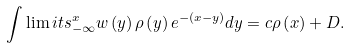<formula> <loc_0><loc_0><loc_500><loc_500>\int \lim i t s _ { - \infty } ^ { x } w \left ( y \right ) \rho \left ( y \right ) e ^ { - \left ( x - y \right ) } d y = c \rho \left ( x \right ) + D .</formula> 